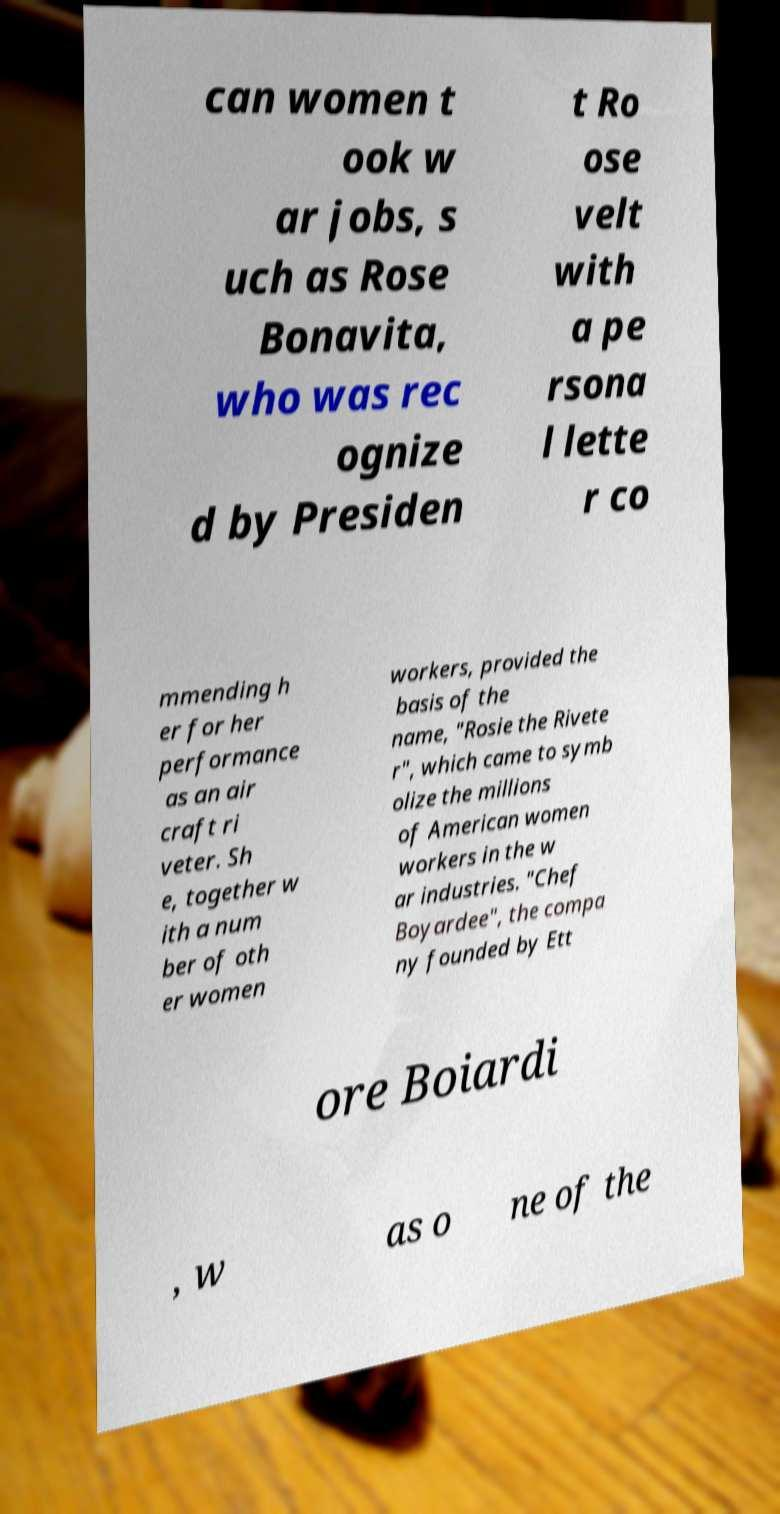Could you extract and type out the text from this image? can women t ook w ar jobs, s uch as Rose Bonavita, who was rec ognize d by Presiden t Ro ose velt with a pe rsona l lette r co mmending h er for her performance as an air craft ri veter. Sh e, together w ith a num ber of oth er women workers, provided the basis of the name, "Rosie the Rivete r", which came to symb olize the millions of American women workers in the w ar industries. "Chef Boyardee", the compa ny founded by Ett ore Boiardi , w as o ne of the 